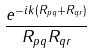<formula> <loc_0><loc_0><loc_500><loc_500>\frac { e ^ { - i k ( R _ { p q } + R _ { q r } ) } } { R _ { p q } R _ { q r } }</formula> 